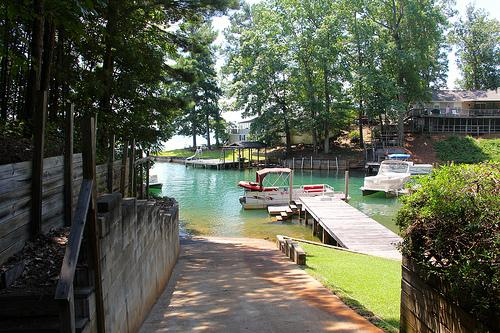Question: what is seen in the picture?
Choices:
A. A scary clown.
B. Boat.
C. Litter.
D. Leaves.
Answer with the letter. Answer: B 